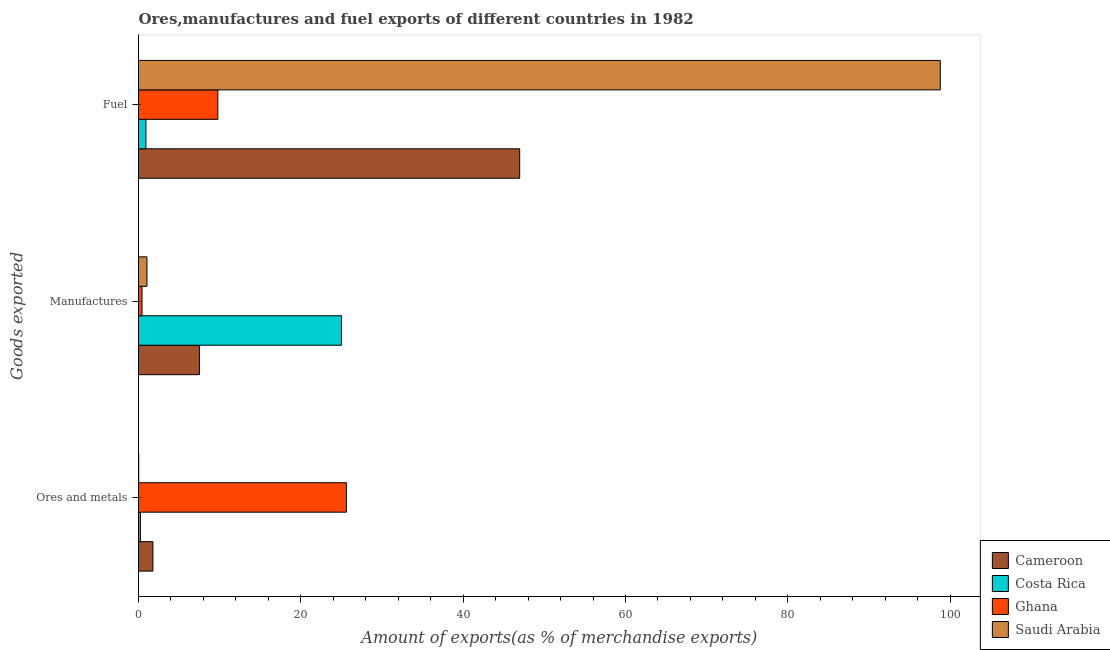Are the number of bars per tick equal to the number of legend labels?
Provide a succinct answer. Yes. How many bars are there on the 3rd tick from the top?
Your answer should be very brief. 4. How many bars are there on the 1st tick from the bottom?
Make the answer very short. 4. What is the label of the 2nd group of bars from the top?
Your response must be concise. Manufactures. What is the percentage of manufactures exports in Ghana?
Provide a succinct answer. 0.43. Across all countries, what is the maximum percentage of fuel exports?
Your response must be concise. 98.79. Across all countries, what is the minimum percentage of fuel exports?
Provide a short and direct response. 0.91. In which country was the percentage of fuel exports maximum?
Offer a very short reply. Saudi Arabia. What is the total percentage of manufactures exports in the graph?
Make the answer very short. 33.99. What is the difference between the percentage of fuel exports in Cameroon and that in Costa Rica?
Offer a very short reply. 46.05. What is the difference between the percentage of ores and metals exports in Cameroon and the percentage of manufactures exports in Saudi Arabia?
Keep it short and to the point. 0.73. What is the average percentage of manufactures exports per country?
Make the answer very short. 8.5. What is the difference between the percentage of fuel exports and percentage of manufactures exports in Ghana?
Provide a succinct answer. 9.34. In how many countries, is the percentage of ores and metals exports greater than 12 %?
Your answer should be very brief. 1. What is the ratio of the percentage of fuel exports in Cameroon to that in Costa Rica?
Provide a short and direct response. 51.39. Is the difference between the percentage of manufactures exports in Costa Rica and Cameroon greater than the difference between the percentage of fuel exports in Costa Rica and Cameroon?
Keep it short and to the point. Yes. What is the difference between the highest and the second highest percentage of ores and metals exports?
Make the answer very short. 23.84. What is the difference between the highest and the lowest percentage of ores and metals exports?
Your answer should be compact. 25.59. What does the 1st bar from the bottom in Manufactures represents?
Your answer should be compact. Cameroon. Are all the bars in the graph horizontal?
Your response must be concise. Yes. How many countries are there in the graph?
Provide a short and direct response. 4. What is the difference between two consecutive major ticks on the X-axis?
Make the answer very short. 20. Are the values on the major ticks of X-axis written in scientific E-notation?
Offer a very short reply. No. Does the graph contain any zero values?
Your answer should be very brief. No. Does the graph contain grids?
Provide a short and direct response. No. How are the legend labels stacked?
Keep it short and to the point. Vertical. What is the title of the graph?
Give a very brief answer. Ores,manufactures and fuel exports of different countries in 1982. What is the label or title of the X-axis?
Provide a succinct answer. Amount of exports(as % of merchandise exports). What is the label or title of the Y-axis?
Your answer should be compact. Goods exported. What is the Amount of exports(as % of merchandise exports) in Cameroon in Ores and metals?
Provide a short and direct response. 1.77. What is the Amount of exports(as % of merchandise exports) in Costa Rica in Ores and metals?
Your answer should be very brief. 0.24. What is the Amount of exports(as % of merchandise exports) in Ghana in Ores and metals?
Offer a very short reply. 25.61. What is the Amount of exports(as % of merchandise exports) in Saudi Arabia in Ores and metals?
Offer a terse response. 0.03. What is the Amount of exports(as % of merchandise exports) in Cameroon in Manufactures?
Your response must be concise. 7.5. What is the Amount of exports(as % of merchandise exports) of Costa Rica in Manufactures?
Make the answer very short. 25.02. What is the Amount of exports(as % of merchandise exports) of Ghana in Manufactures?
Offer a terse response. 0.43. What is the Amount of exports(as % of merchandise exports) of Saudi Arabia in Manufactures?
Keep it short and to the point. 1.04. What is the Amount of exports(as % of merchandise exports) of Cameroon in Fuel?
Your answer should be compact. 46.96. What is the Amount of exports(as % of merchandise exports) in Costa Rica in Fuel?
Keep it short and to the point. 0.91. What is the Amount of exports(as % of merchandise exports) of Ghana in Fuel?
Keep it short and to the point. 9.77. What is the Amount of exports(as % of merchandise exports) in Saudi Arabia in Fuel?
Provide a succinct answer. 98.79. Across all Goods exported, what is the maximum Amount of exports(as % of merchandise exports) in Cameroon?
Your response must be concise. 46.96. Across all Goods exported, what is the maximum Amount of exports(as % of merchandise exports) of Costa Rica?
Your response must be concise. 25.02. Across all Goods exported, what is the maximum Amount of exports(as % of merchandise exports) of Ghana?
Your answer should be very brief. 25.61. Across all Goods exported, what is the maximum Amount of exports(as % of merchandise exports) in Saudi Arabia?
Offer a terse response. 98.79. Across all Goods exported, what is the minimum Amount of exports(as % of merchandise exports) of Cameroon?
Your response must be concise. 1.77. Across all Goods exported, what is the minimum Amount of exports(as % of merchandise exports) of Costa Rica?
Ensure brevity in your answer.  0.24. Across all Goods exported, what is the minimum Amount of exports(as % of merchandise exports) in Ghana?
Provide a succinct answer. 0.43. Across all Goods exported, what is the minimum Amount of exports(as % of merchandise exports) of Saudi Arabia?
Ensure brevity in your answer.  0.03. What is the total Amount of exports(as % of merchandise exports) of Cameroon in the graph?
Your response must be concise. 56.24. What is the total Amount of exports(as % of merchandise exports) of Costa Rica in the graph?
Make the answer very short. 26.17. What is the total Amount of exports(as % of merchandise exports) in Ghana in the graph?
Provide a short and direct response. 35.82. What is the total Amount of exports(as % of merchandise exports) of Saudi Arabia in the graph?
Your answer should be very brief. 99.85. What is the difference between the Amount of exports(as % of merchandise exports) of Cameroon in Ores and metals and that in Manufactures?
Your answer should be very brief. -5.73. What is the difference between the Amount of exports(as % of merchandise exports) of Costa Rica in Ores and metals and that in Manufactures?
Ensure brevity in your answer.  -24.78. What is the difference between the Amount of exports(as % of merchandise exports) in Ghana in Ores and metals and that in Manufactures?
Ensure brevity in your answer.  25.18. What is the difference between the Amount of exports(as % of merchandise exports) in Saudi Arabia in Ores and metals and that in Manufactures?
Your answer should be very brief. -1.02. What is the difference between the Amount of exports(as % of merchandise exports) in Cameroon in Ores and metals and that in Fuel?
Make the answer very short. -45.19. What is the difference between the Amount of exports(as % of merchandise exports) of Costa Rica in Ores and metals and that in Fuel?
Provide a succinct answer. -0.68. What is the difference between the Amount of exports(as % of merchandise exports) of Ghana in Ores and metals and that in Fuel?
Your answer should be compact. 15.84. What is the difference between the Amount of exports(as % of merchandise exports) in Saudi Arabia in Ores and metals and that in Fuel?
Ensure brevity in your answer.  -98.76. What is the difference between the Amount of exports(as % of merchandise exports) in Cameroon in Manufactures and that in Fuel?
Keep it short and to the point. -39.46. What is the difference between the Amount of exports(as % of merchandise exports) of Costa Rica in Manufactures and that in Fuel?
Provide a short and direct response. 24.1. What is the difference between the Amount of exports(as % of merchandise exports) of Ghana in Manufactures and that in Fuel?
Offer a very short reply. -9.34. What is the difference between the Amount of exports(as % of merchandise exports) in Saudi Arabia in Manufactures and that in Fuel?
Offer a terse response. -97.75. What is the difference between the Amount of exports(as % of merchandise exports) of Cameroon in Ores and metals and the Amount of exports(as % of merchandise exports) of Costa Rica in Manufactures?
Provide a succinct answer. -23.24. What is the difference between the Amount of exports(as % of merchandise exports) in Cameroon in Ores and metals and the Amount of exports(as % of merchandise exports) in Ghana in Manufactures?
Make the answer very short. 1.34. What is the difference between the Amount of exports(as % of merchandise exports) of Cameroon in Ores and metals and the Amount of exports(as % of merchandise exports) of Saudi Arabia in Manufactures?
Keep it short and to the point. 0.73. What is the difference between the Amount of exports(as % of merchandise exports) in Costa Rica in Ores and metals and the Amount of exports(as % of merchandise exports) in Ghana in Manufactures?
Your answer should be compact. -0.2. What is the difference between the Amount of exports(as % of merchandise exports) of Costa Rica in Ores and metals and the Amount of exports(as % of merchandise exports) of Saudi Arabia in Manufactures?
Provide a short and direct response. -0.8. What is the difference between the Amount of exports(as % of merchandise exports) in Ghana in Ores and metals and the Amount of exports(as % of merchandise exports) in Saudi Arabia in Manufactures?
Your response must be concise. 24.57. What is the difference between the Amount of exports(as % of merchandise exports) of Cameroon in Ores and metals and the Amount of exports(as % of merchandise exports) of Costa Rica in Fuel?
Offer a very short reply. 0.86. What is the difference between the Amount of exports(as % of merchandise exports) in Cameroon in Ores and metals and the Amount of exports(as % of merchandise exports) in Ghana in Fuel?
Your answer should be compact. -8. What is the difference between the Amount of exports(as % of merchandise exports) in Cameroon in Ores and metals and the Amount of exports(as % of merchandise exports) in Saudi Arabia in Fuel?
Provide a succinct answer. -97.01. What is the difference between the Amount of exports(as % of merchandise exports) in Costa Rica in Ores and metals and the Amount of exports(as % of merchandise exports) in Ghana in Fuel?
Your response must be concise. -9.54. What is the difference between the Amount of exports(as % of merchandise exports) in Costa Rica in Ores and metals and the Amount of exports(as % of merchandise exports) in Saudi Arabia in Fuel?
Provide a short and direct response. -98.55. What is the difference between the Amount of exports(as % of merchandise exports) in Ghana in Ores and metals and the Amount of exports(as % of merchandise exports) in Saudi Arabia in Fuel?
Offer a terse response. -73.17. What is the difference between the Amount of exports(as % of merchandise exports) in Cameroon in Manufactures and the Amount of exports(as % of merchandise exports) in Costa Rica in Fuel?
Give a very brief answer. 6.59. What is the difference between the Amount of exports(as % of merchandise exports) in Cameroon in Manufactures and the Amount of exports(as % of merchandise exports) in Ghana in Fuel?
Your answer should be very brief. -2.27. What is the difference between the Amount of exports(as % of merchandise exports) in Cameroon in Manufactures and the Amount of exports(as % of merchandise exports) in Saudi Arabia in Fuel?
Make the answer very short. -91.28. What is the difference between the Amount of exports(as % of merchandise exports) in Costa Rica in Manufactures and the Amount of exports(as % of merchandise exports) in Ghana in Fuel?
Ensure brevity in your answer.  15.24. What is the difference between the Amount of exports(as % of merchandise exports) in Costa Rica in Manufactures and the Amount of exports(as % of merchandise exports) in Saudi Arabia in Fuel?
Your response must be concise. -73.77. What is the difference between the Amount of exports(as % of merchandise exports) in Ghana in Manufactures and the Amount of exports(as % of merchandise exports) in Saudi Arabia in Fuel?
Give a very brief answer. -98.36. What is the average Amount of exports(as % of merchandise exports) of Cameroon per Goods exported?
Make the answer very short. 18.75. What is the average Amount of exports(as % of merchandise exports) in Costa Rica per Goods exported?
Keep it short and to the point. 8.72. What is the average Amount of exports(as % of merchandise exports) in Ghana per Goods exported?
Your answer should be very brief. 11.94. What is the average Amount of exports(as % of merchandise exports) of Saudi Arabia per Goods exported?
Provide a succinct answer. 33.28. What is the difference between the Amount of exports(as % of merchandise exports) of Cameroon and Amount of exports(as % of merchandise exports) of Costa Rica in Ores and metals?
Your response must be concise. 1.54. What is the difference between the Amount of exports(as % of merchandise exports) in Cameroon and Amount of exports(as % of merchandise exports) in Ghana in Ores and metals?
Offer a very short reply. -23.84. What is the difference between the Amount of exports(as % of merchandise exports) in Cameroon and Amount of exports(as % of merchandise exports) in Saudi Arabia in Ores and metals?
Give a very brief answer. 1.75. What is the difference between the Amount of exports(as % of merchandise exports) of Costa Rica and Amount of exports(as % of merchandise exports) of Ghana in Ores and metals?
Your answer should be compact. -25.38. What is the difference between the Amount of exports(as % of merchandise exports) of Costa Rica and Amount of exports(as % of merchandise exports) of Saudi Arabia in Ores and metals?
Make the answer very short. 0.21. What is the difference between the Amount of exports(as % of merchandise exports) of Ghana and Amount of exports(as % of merchandise exports) of Saudi Arabia in Ores and metals?
Make the answer very short. 25.59. What is the difference between the Amount of exports(as % of merchandise exports) in Cameroon and Amount of exports(as % of merchandise exports) in Costa Rica in Manufactures?
Your answer should be very brief. -17.51. What is the difference between the Amount of exports(as % of merchandise exports) in Cameroon and Amount of exports(as % of merchandise exports) in Ghana in Manufactures?
Give a very brief answer. 7.07. What is the difference between the Amount of exports(as % of merchandise exports) in Cameroon and Amount of exports(as % of merchandise exports) in Saudi Arabia in Manufactures?
Ensure brevity in your answer.  6.46. What is the difference between the Amount of exports(as % of merchandise exports) in Costa Rica and Amount of exports(as % of merchandise exports) in Ghana in Manufactures?
Give a very brief answer. 24.58. What is the difference between the Amount of exports(as % of merchandise exports) of Costa Rica and Amount of exports(as % of merchandise exports) of Saudi Arabia in Manufactures?
Give a very brief answer. 23.97. What is the difference between the Amount of exports(as % of merchandise exports) in Ghana and Amount of exports(as % of merchandise exports) in Saudi Arabia in Manufactures?
Keep it short and to the point. -0.61. What is the difference between the Amount of exports(as % of merchandise exports) in Cameroon and Amount of exports(as % of merchandise exports) in Costa Rica in Fuel?
Your answer should be very brief. 46.05. What is the difference between the Amount of exports(as % of merchandise exports) of Cameroon and Amount of exports(as % of merchandise exports) of Ghana in Fuel?
Offer a very short reply. 37.19. What is the difference between the Amount of exports(as % of merchandise exports) of Cameroon and Amount of exports(as % of merchandise exports) of Saudi Arabia in Fuel?
Ensure brevity in your answer.  -51.82. What is the difference between the Amount of exports(as % of merchandise exports) in Costa Rica and Amount of exports(as % of merchandise exports) in Ghana in Fuel?
Your response must be concise. -8.86. What is the difference between the Amount of exports(as % of merchandise exports) of Costa Rica and Amount of exports(as % of merchandise exports) of Saudi Arabia in Fuel?
Your answer should be compact. -97.87. What is the difference between the Amount of exports(as % of merchandise exports) in Ghana and Amount of exports(as % of merchandise exports) in Saudi Arabia in Fuel?
Offer a terse response. -89.01. What is the ratio of the Amount of exports(as % of merchandise exports) of Cameroon in Ores and metals to that in Manufactures?
Give a very brief answer. 0.24. What is the ratio of the Amount of exports(as % of merchandise exports) in Costa Rica in Ores and metals to that in Manufactures?
Offer a very short reply. 0.01. What is the ratio of the Amount of exports(as % of merchandise exports) in Ghana in Ores and metals to that in Manufactures?
Offer a very short reply. 59.38. What is the ratio of the Amount of exports(as % of merchandise exports) in Saudi Arabia in Ores and metals to that in Manufactures?
Keep it short and to the point. 0.02. What is the ratio of the Amount of exports(as % of merchandise exports) of Cameroon in Ores and metals to that in Fuel?
Ensure brevity in your answer.  0.04. What is the ratio of the Amount of exports(as % of merchandise exports) in Costa Rica in Ores and metals to that in Fuel?
Offer a terse response. 0.26. What is the ratio of the Amount of exports(as % of merchandise exports) in Ghana in Ores and metals to that in Fuel?
Your answer should be very brief. 2.62. What is the ratio of the Amount of exports(as % of merchandise exports) of Cameroon in Manufactures to that in Fuel?
Your answer should be very brief. 0.16. What is the ratio of the Amount of exports(as % of merchandise exports) of Costa Rica in Manufactures to that in Fuel?
Give a very brief answer. 27.37. What is the ratio of the Amount of exports(as % of merchandise exports) of Ghana in Manufactures to that in Fuel?
Give a very brief answer. 0.04. What is the ratio of the Amount of exports(as % of merchandise exports) in Saudi Arabia in Manufactures to that in Fuel?
Offer a terse response. 0.01. What is the difference between the highest and the second highest Amount of exports(as % of merchandise exports) in Cameroon?
Give a very brief answer. 39.46. What is the difference between the highest and the second highest Amount of exports(as % of merchandise exports) of Costa Rica?
Give a very brief answer. 24.1. What is the difference between the highest and the second highest Amount of exports(as % of merchandise exports) in Ghana?
Your answer should be compact. 15.84. What is the difference between the highest and the second highest Amount of exports(as % of merchandise exports) in Saudi Arabia?
Your answer should be compact. 97.75. What is the difference between the highest and the lowest Amount of exports(as % of merchandise exports) of Cameroon?
Offer a very short reply. 45.19. What is the difference between the highest and the lowest Amount of exports(as % of merchandise exports) of Costa Rica?
Your answer should be compact. 24.78. What is the difference between the highest and the lowest Amount of exports(as % of merchandise exports) of Ghana?
Ensure brevity in your answer.  25.18. What is the difference between the highest and the lowest Amount of exports(as % of merchandise exports) in Saudi Arabia?
Ensure brevity in your answer.  98.76. 